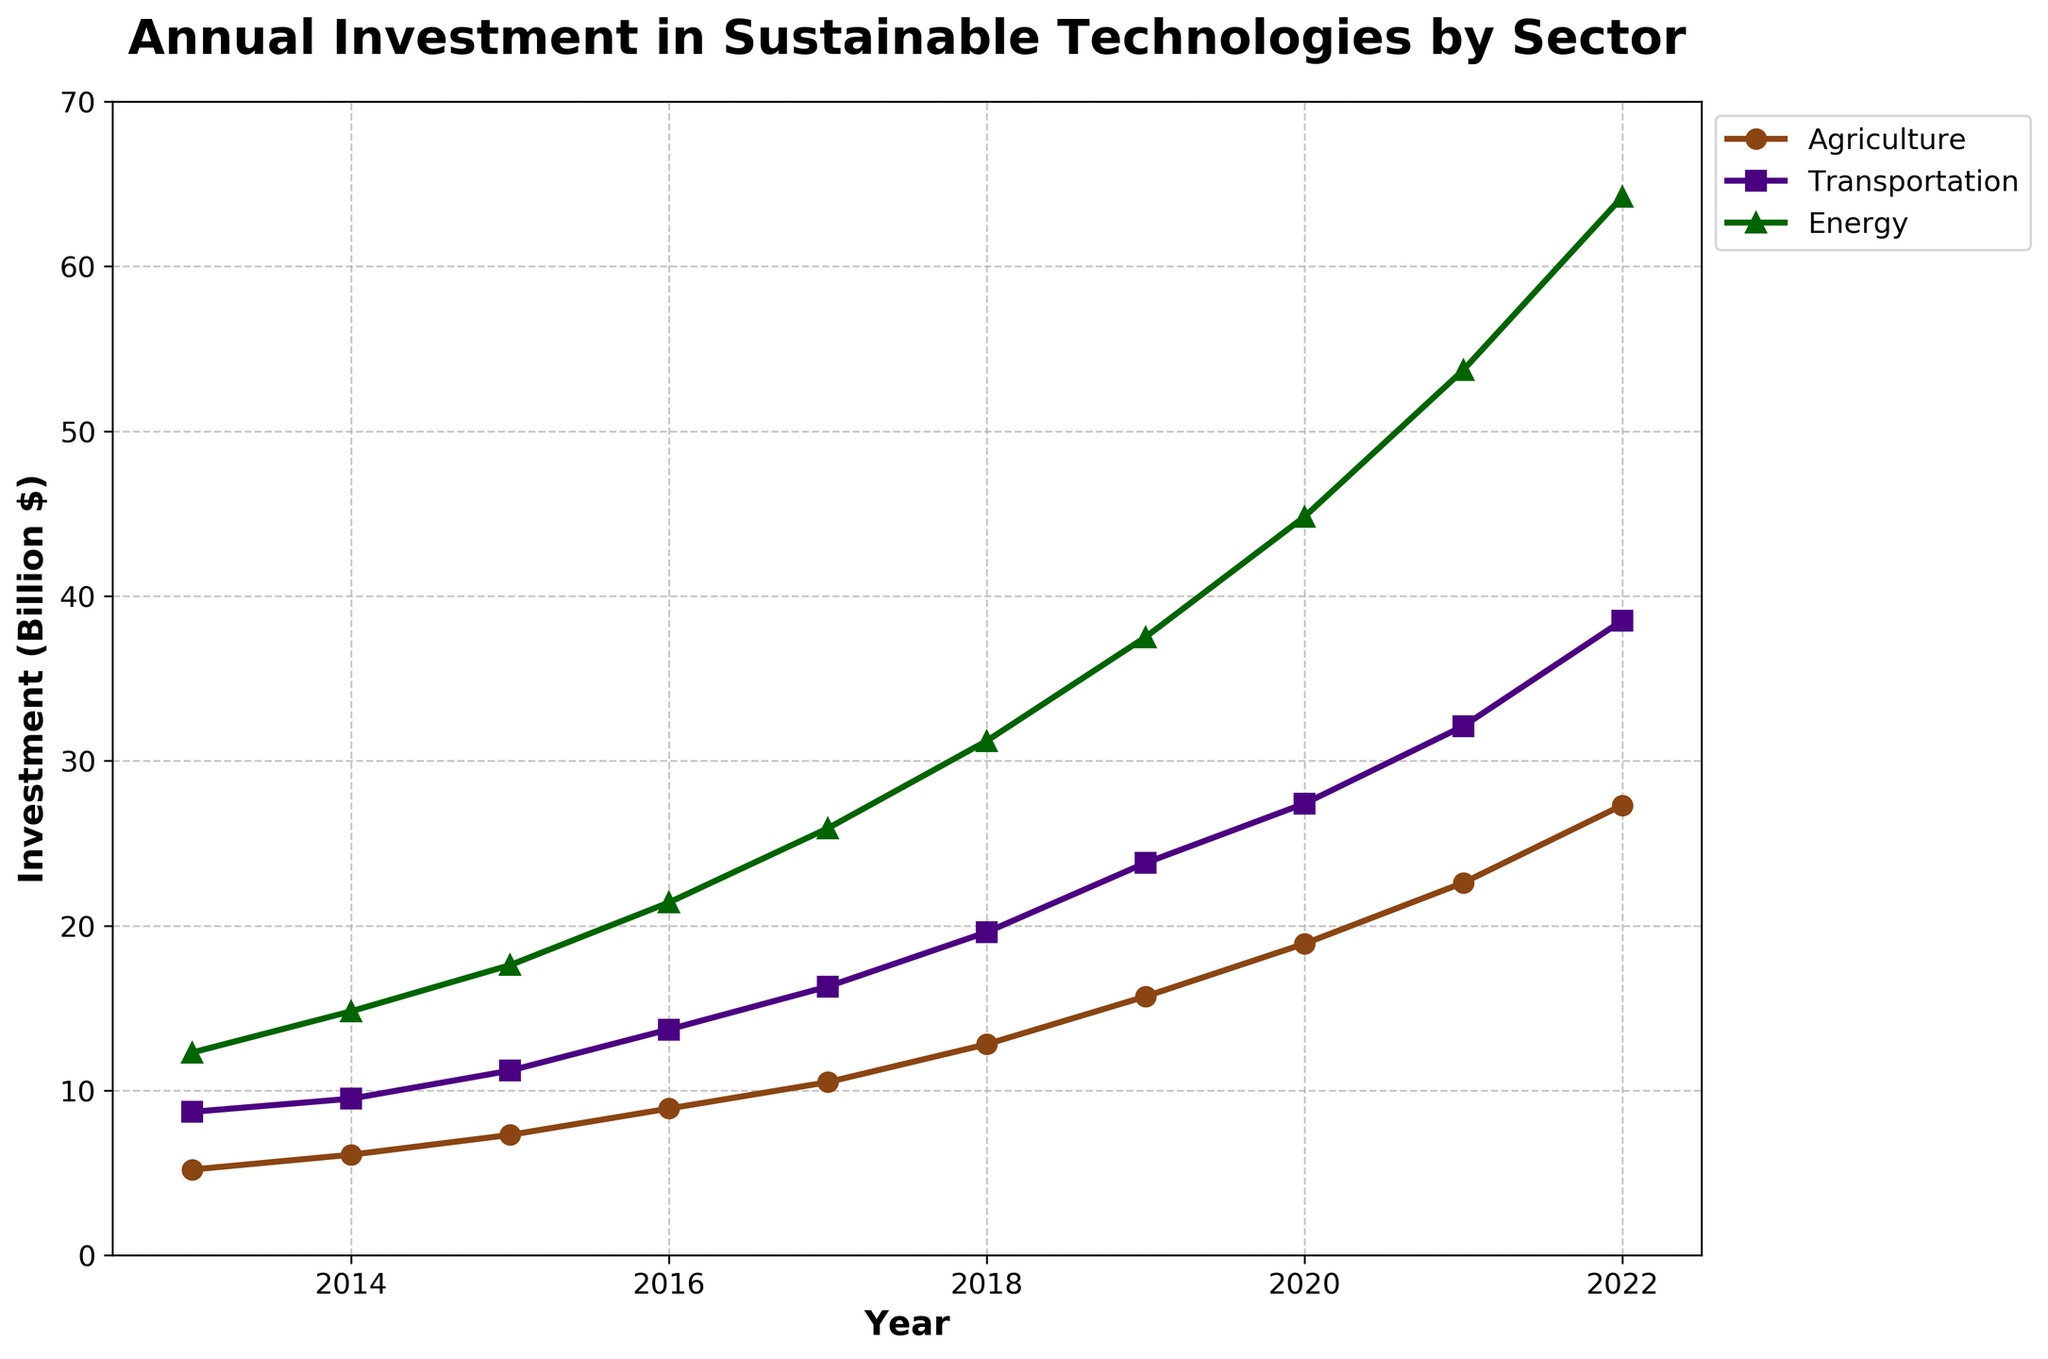What's the trend in investment in the Energy sector from 2013 to 2022? The Energy sector shows a steady increase in investment over time. In 2013, it was 12.3 billion dollars, and by 2022, it grew to 64.2 billion dollars. This indicates a positive trend.
Answer: Steady increase Which sector had the highest investment in 2018? In 2018, the Energy sector had the highest investment. The chart shows the Energy sector at approximately 31.2 billion dollars, which is higher than both Agriculture and Transportation.
Answer: Energy By how much did the investment in Transportation increase from 2013 to 2022? In 2013, the investment in Transportation was 8.7 billion dollars. By 2022, it was 38.5 billion dollars. The increase is 38.5 - 8.7 = 29.8 billion dollars.
Answer: 29.8 billion dollars How does the investment in Agriculture in 2022 compare to the investment in Energy in 2016? In 2022, the investment in Agriculture was 27.3 billion dollars. The investment in Energy in 2016 was 21.4 billion dollars. Thus, the investment in Agriculture in 2022 is higher by 27.3 - 21.4 = 5.9 billion dollars.
Answer: 5.9 billion dollars higher What is the average annual investment in the Transportation sector from 2013 to 2022? The total investment from 2013 to 2022 (10 years) for Transportation is the sum of all the annual investments: 8.7 + 9.5 + 11.2 + 13.7 + 16.3 + 19.6 + 23.8 + 27.4 + 32.1 + 38.5 = 200.8 billion dollars. The average investment is 200.8/10 = 20.08 billion dollars per year.
Answer: 20.08 billion dollars per year In which year did the investment in Agriculture first surpass 10 billion dollars? According to the plot, the investment in Agriculture surpassed 10 billion dollars in 2017, where it reached 10.5 billion dollars.
Answer: 2017 Which sector consistently received the lowest investment over the decade? The Agriculture sector consistently received the lowest investment compared to the Transportation and Energy sectors over the decade as indicated by the lower line on the plot throughout all years.
Answer: Agriculture What is the difference in the investment between Agriculture and Transportation in 2015? In 2015, the investment in Agriculture was 7.3 billion dollars, and in Transportation, it was 11.2 billion dollars. The difference is 11.2 - 7.3 = 3.9 billion dollars.
Answer: 3.9 billion dollars Which sector shows the steepest increase in investment over the decade? The Energy sector shows the steepest increase in investment over the decade. From 12.3 billion dollars in 2013 to 64.2 billion dollars in 2022, the slope of its line is the steepest among the three sectors.
Answer: Energy Is there any year where the investment in Transportation was higher than in Energy? No, according to the plot, at no point between 2013 and 2022 did the investment in Transportation exceed that of Energy. Energy consistently had higher investment.
Answer: No 